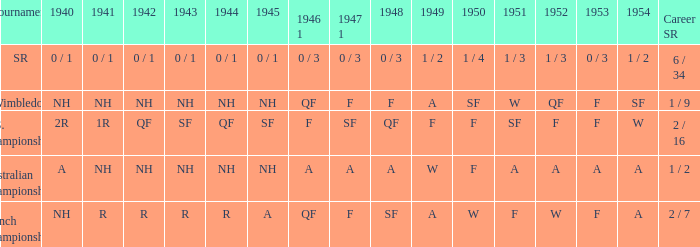What is the contest that had a conclusion of a in 1954 and nh in 1942? Australian Championships. 